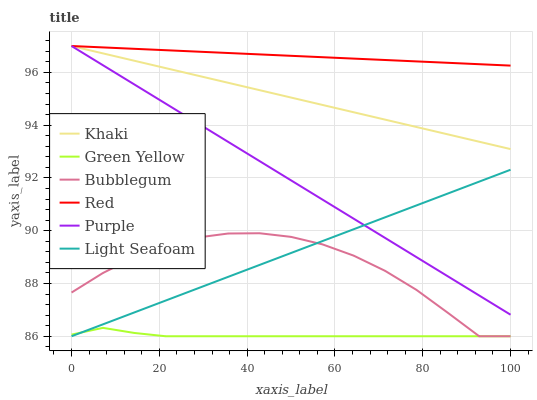Does Green Yellow have the minimum area under the curve?
Answer yes or no. Yes. Does Red have the maximum area under the curve?
Answer yes or no. Yes. Does Purple have the minimum area under the curve?
Answer yes or no. No. Does Purple have the maximum area under the curve?
Answer yes or no. No. Is Red the smoothest?
Answer yes or no. Yes. Is Bubblegum the roughest?
Answer yes or no. Yes. Is Purple the smoothest?
Answer yes or no. No. Is Purple the roughest?
Answer yes or no. No. Does Bubblegum have the lowest value?
Answer yes or no. Yes. Does Purple have the lowest value?
Answer yes or no. No. Does Red have the highest value?
Answer yes or no. Yes. Does Bubblegum have the highest value?
Answer yes or no. No. Is Bubblegum less than Red?
Answer yes or no. Yes. Is Khaki greater than Green Yellow?
Answer yes or no. Yes. Does Red intersect Purple?
Answer yes or no. Yes. Is Red less than Purple?
Answer yes or no. No. Is Red greater than Purple?
Answer yes or no. No. Does Bubblegum intersect Red?
Answer yes or no. No. 